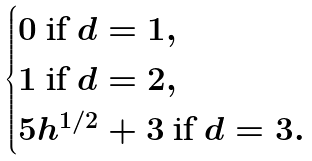Convert formula to latex. <formula><loc_0><loc_0><loc_500><loc_500>\begin{cases} 0 \text { if } d = 1 , \\ 1 \text { if } d = 2 , \\ 5 h ^ { 1 / 2 } + 3 \text { if } d = 3 . \\ \end{cases}</formula> 